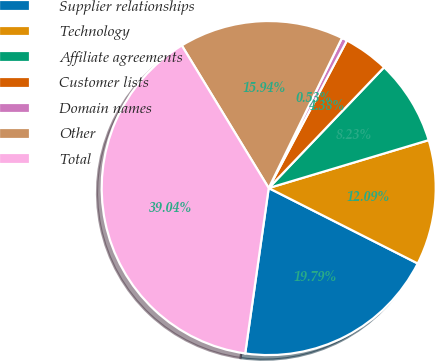Convert chart to OTSL. <chart><loc_0><loc_0><loc_500><loc_500><pie_chart><fcel>Supplier relationships<fcel>Technology<fcel>Affiliate agreements<fcel>Customer lists<fcel>Domain names<fcel>Other<fcel>Total<nl><fcel>19.79%<fcel>12.09%<fcel>8.23%<fcel>4.38%<fcel>0.53%<fcel>15.94%<fcel>39.04%<nl></chart> 